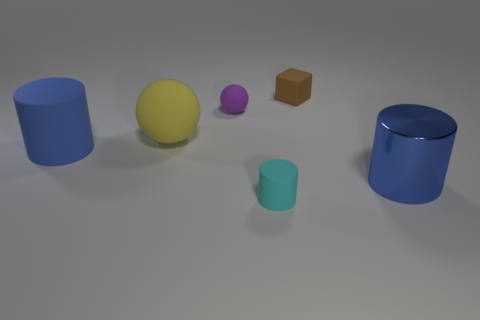Add 4 small cyan matte objects. How many objects exist? 10 Subtract all blocks. How many objects are left? 5 Add 2 yellow spheres. How many yellow spheres are left? 3 Add 1 yellow matte objects. How many yellow matte objects exist? 2 Subtract 0 gray spheres. How many objects are left? 6 Subtract all cyan things. Subtract all big yellow matte objects. How many objects are left? 4 